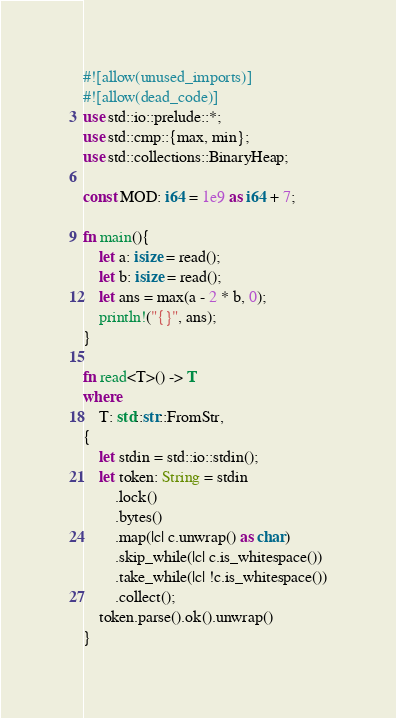Convert code to text. <code><loc_0><loc_0><loc_500><loc_500><_Rust_>#![allow(unused_imports)]
#![allow(dead_code)]
use std::io::prelude::*;
use std::cmp::{max, min};
use std::collections::BinaryHeap;

const MOD: i64 = 1e9 as i64 + 7;

fn main(){
    let a: isize = read();
    let b: isize = read();
    let ans = max(a - 2 * b, 0);
    println!("{}", ans);
}

fn read<T>() -> T
where
    T: std::str::FromStr,
{
    let stdin = std::io::stdin();
    let token: String = stdin
        .lock()
        .bytes()
        .map(|c| c.unwrap() as char)
        .skip_while(|c| c.is_whitespace())
        .take_while(|c| !c.is_whitespace())
        .collect();
    token.parse().ok().unwrap()
}
</code> 